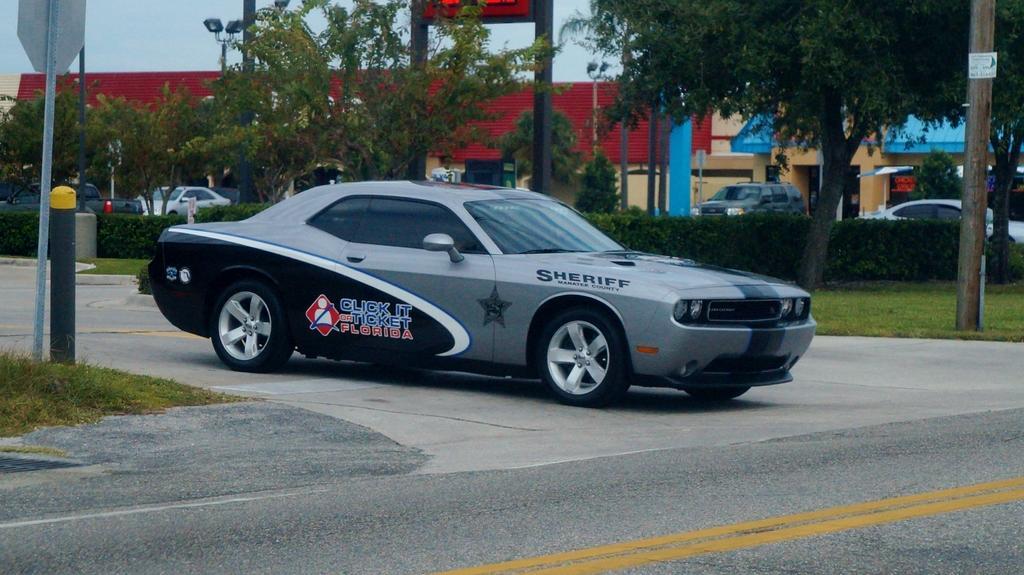In one or two sentences, can you explain what this image depicts? In this picture I can observe a car on the road. The car is in grey and black color. On the left side I can observe two poles. In the background there are some trees and houses. 